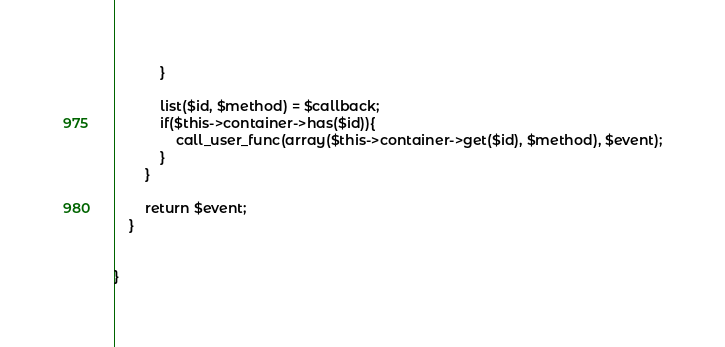Convert code to text. <code><loc_0><loc_0><loc_500><loc_500><_PHP_>            }

            list($id, $method) = $callback;
            if($this->container->has($id)){
                call_user_func(array($this->container->get($id), $method), $event);
            }
        }

        return $event;
    }


}</code> 